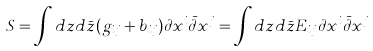Convert formula to latex. <formula><loc_0><loc_0><loc_500><loc_500>S = \int d z d \bar { z } ( g _ { i j } + b _ { i j } ) \partial x ^ { i } \bar { \partial } x ^ { j } = \int d z d \bar { z } E _ { i j } \partial x ^ { i } \bar { \partial } x ^ { j }</formula> 